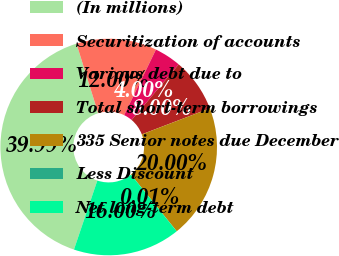Convert chart. <chart><loc_0><loc_0><loc_500><loc_500><pie_chart><fcel>(In millions)<fcel>Securitization of accounts<fcel>Various debt due to<fcel>Total short-term borrowings<fcel>335 Senior notes due December<fcel>Less Discount<fcel>Net long-term debt<nl><fcel>39.99%<fcel>12.0%<fcel>4.0%<fcel>8.0%<fcel>20.0%<fcel>0.01%<fcel>16.0%<nl></chart> 